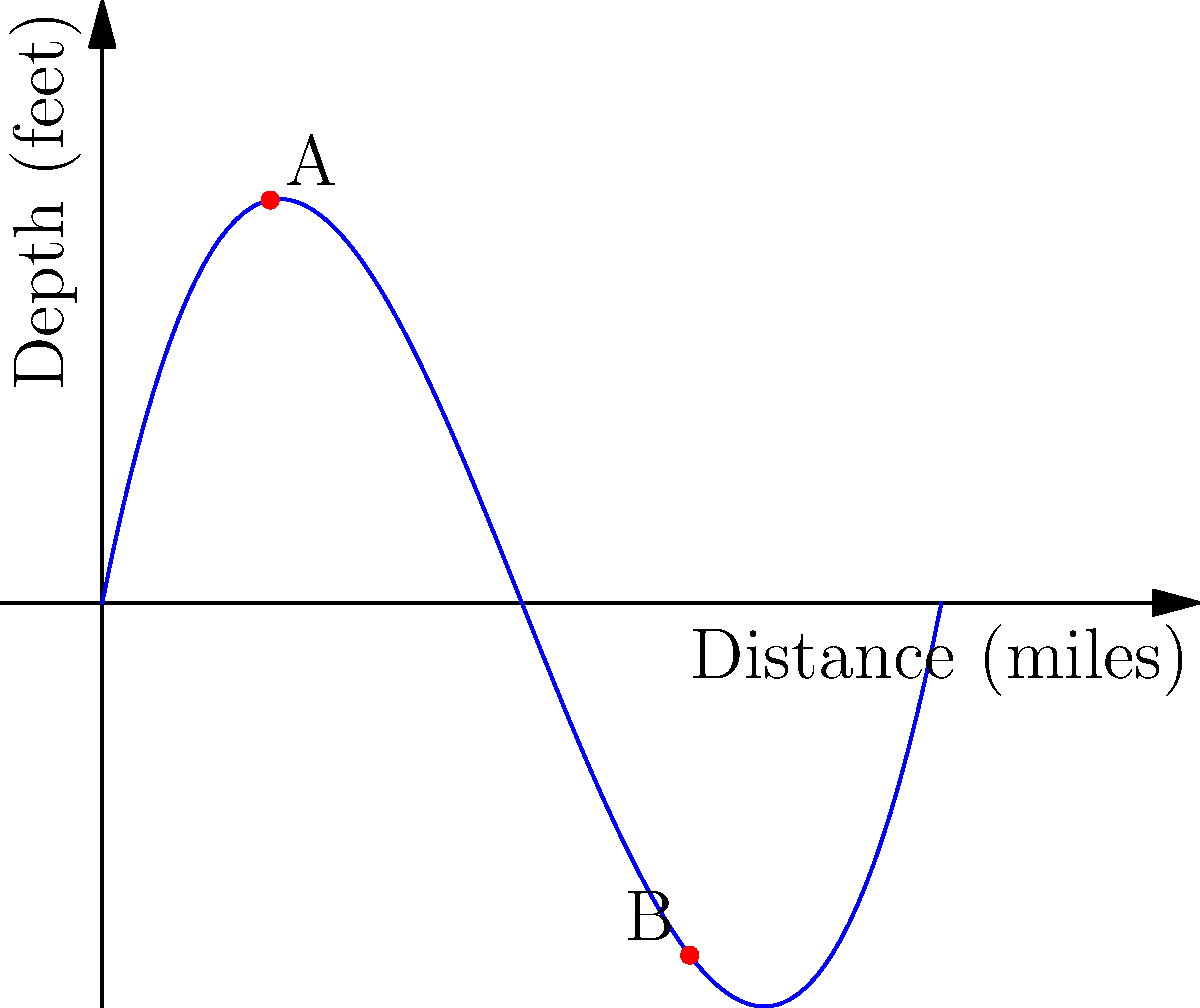Old Jim's favorite fishing spot is along Crooked Creek, which follows a path described by the function $y = 0.1x^3 - 1.5x^2 + 5x$, where $x$ is the distance in miles from the creek's source, and $y$ is the depth in feet. Jim knows the best fishing spots are where the creek is 10 feet deep. Using your trusty paper map and keen eye, determine how many miles apart the two prime fishing locations (marked as A and B on the map) are from each other. To solve this problem, we'll follow these steps:

1) We need to find the $x$ values (distances) where the depth is 10 feet. This means solving the equation:

   $10 = 0.1x^3 - 1.5x^2 + 5x$

2) Rearranging the equation:

   $0.1x^3 - 1.5x^2 + 5x - 10 = 0$

3) This is a cubic equation. By inspection or using a graphing method, we can see that it has two solutions in the range we're interested in (0 to 10 miles).

4) These solutions are approximately $x = 2$ and $x = 7$, which correspond to points A and B on the graph.

5) To find the distance between these points, we simply subtract:

   $7 - 2 = 5$

Therefore, the two prime fishing locations are 5 miles apart along the creek.
Answer: 5 miles 